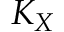<formula> <loc_0><loc_0><loc_500><loc_500>K _ { X }</formula> 